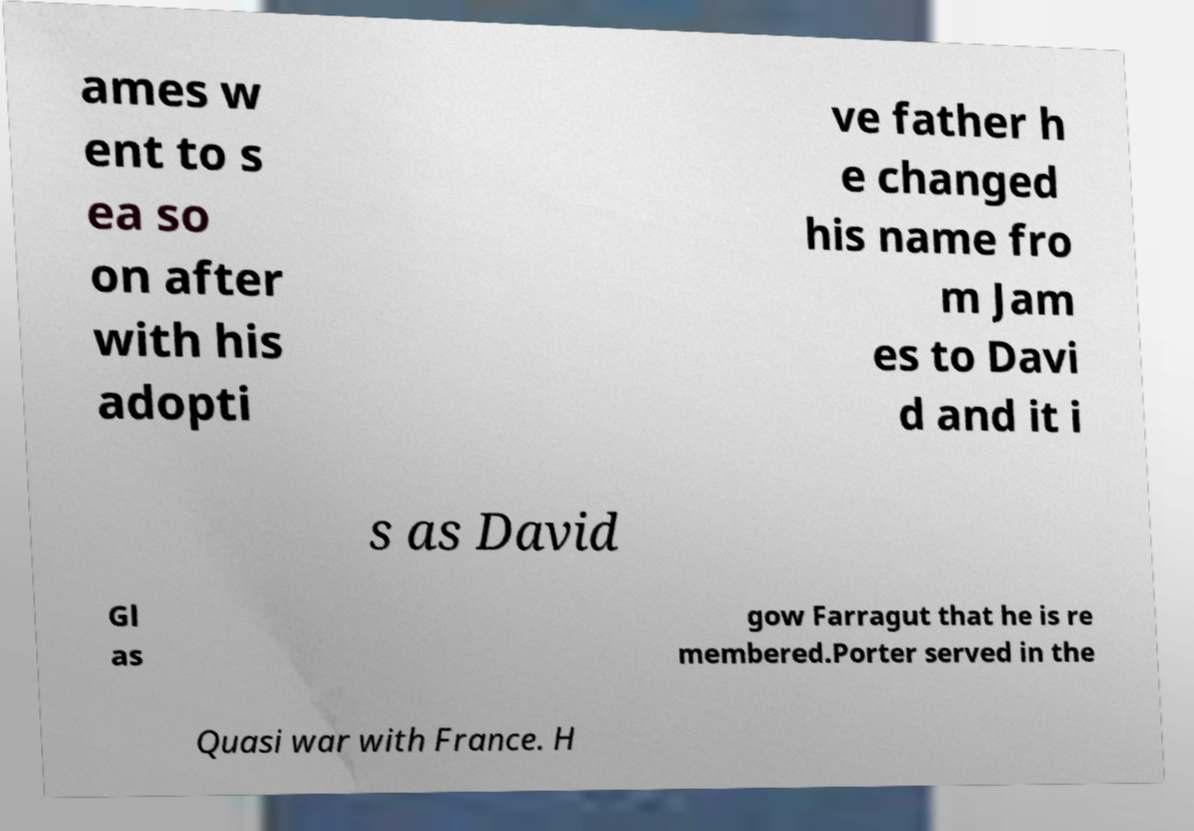Could you extract and type out the text from this image? ames w ent to s ea so on after with his adopti ve father h e changed his name fro m Jam es to Davi d and it i s as David Gl as gow Farragut that he is re membered.Porter served in the Quasi war with France. H 